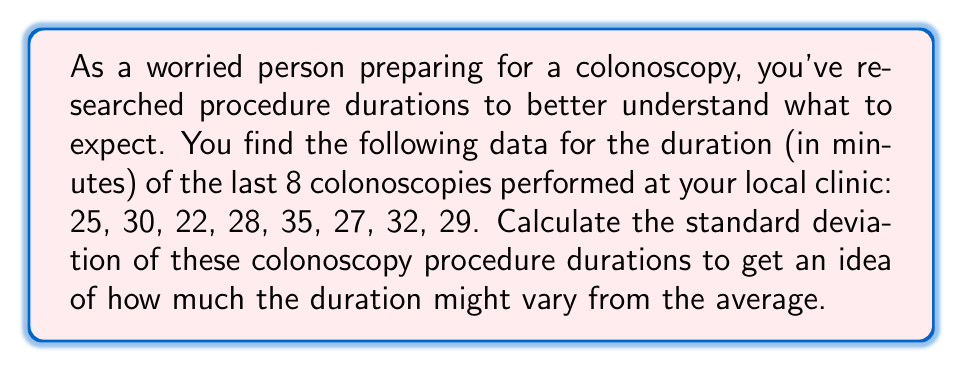Give your solution to this math problem. To calculate the standard deviation, we'll follow these steps:

1. Calculate the mean ($\mu$) of the dataset:
   $$\mu = \frac{25 + 30 + 22 + 28 + 35 + 27 + 32 + 29}{8} = \frac{228}{8} = 28.5$$

2. Calculate the squared differences from the mean:
   $$(25 - 28.5)^2 = (-3.5)^2 = 12.25$$
   $$(30 - 28.5)^2 = (1.5)^2 = 2.25$$
   $$(22 - 28.5)^2 = (-6.5)^2 = 42.25$$
   $$(28 - 28.5)^2 = (-0.5)^2 = 0.25$$
   $$(35 - 28.5)^2 = (6.5)^2 = 42.25$$
   $$(27 - 28.5)^2 = (-1.5)^2 = 2.25$$
   $$(32 - 28.5)^2 = (3.5)^2 = 12.25$$
   $$(29 - 28.5)^2 = (0.5)^2 = 0.25$$

3. Sum the squared differences:
   $$12.25 + 2.25 + 42.25 + 0.25 + 42.25 + 2.25 + 12.25 + 0.25 = 114$$

4. Divide by (n-1) = 7 to get the variance:
   $$\text{Variance} = \frac{114}{7} = 16.2857$$

5. Take the square root of the variance to get the standard deviation:
   $$\text{Standard Deviation} = \sqrt{16.2857} \approx 4.0354$$
Answer: The standard deviation of the colonoscopy procedure durations is approximately $4.04$ minutes. 